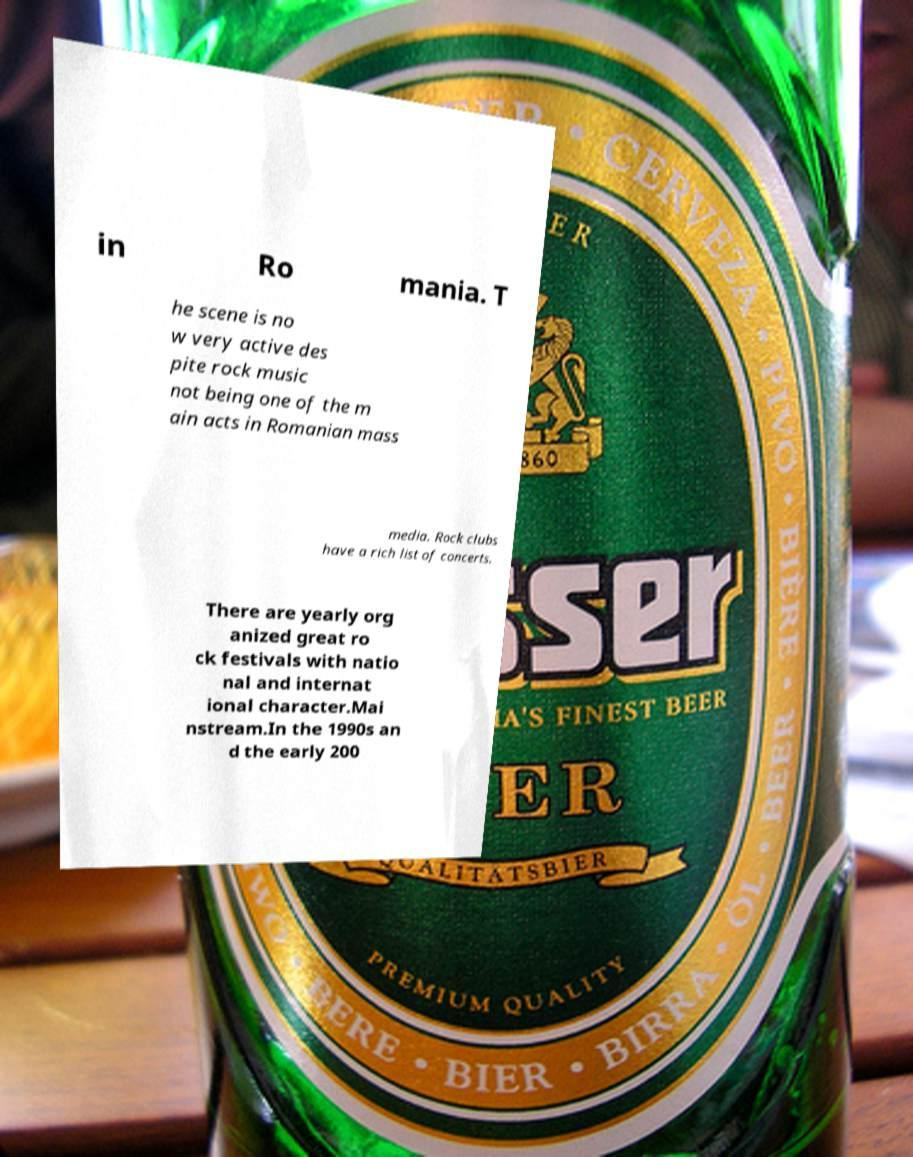Please read and relay the text visible in this image. What does it say? in Ro mania. T he scene is no w very active des pite rock music not being one of the m ain acts in Romanian mass media. Rock clubs have a rich list of concerts. There are yearly org anized great ro ck festivals with natio nal and internat ional character.Mai nstream.In the 1990s an d the early 200 